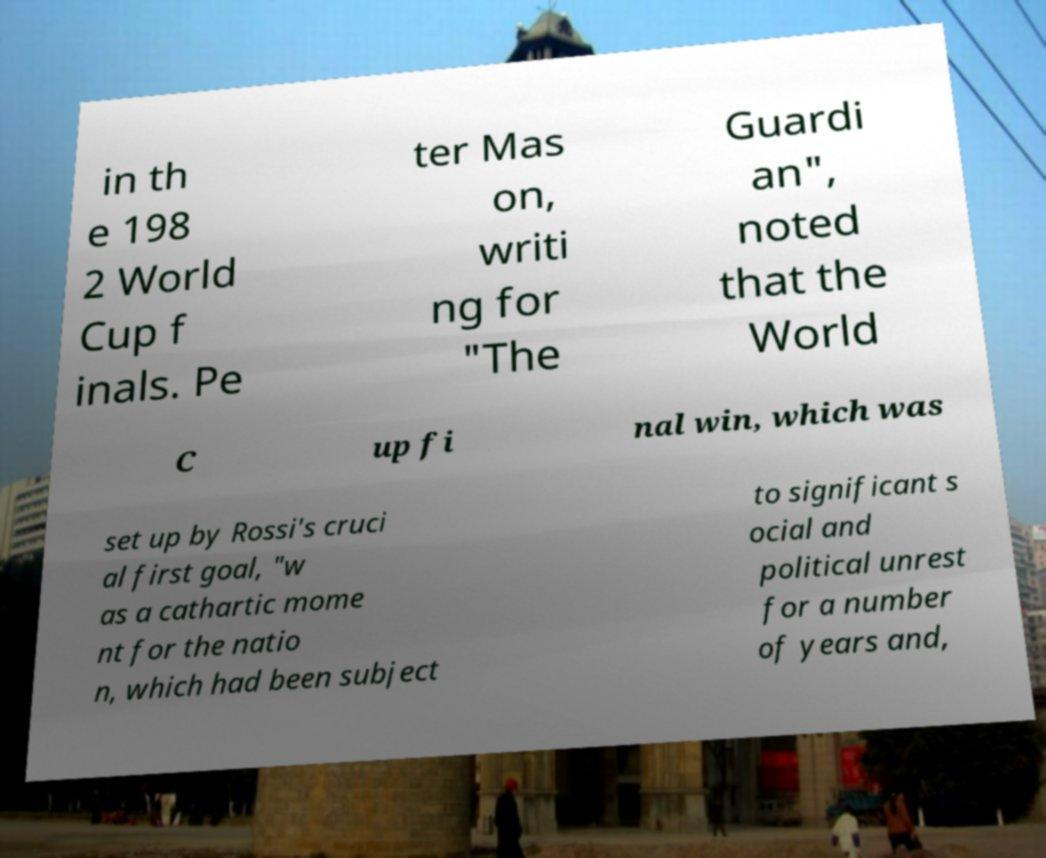Can you accurately transcribe the text from the provided image for me? in th e 198 2 World Cup f inals. Pe ter Mas on, writi ng for "The Guardi an", noted that the World C up fi nal win, which was set up by Rossi's cruci al first goal, "w as a cathartic mome nt for the natio n, which had been subject to significant s ocial and political unrest for a number of years and, 